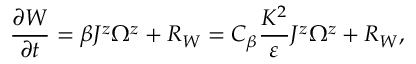Convert formula to latex. <formula><loc_0><loc_0><loc_500><loc_500>\frac { \partial W } { \partial t } = \beta J ^ { z } \Omega ^ { z } + R _ { W } = C _ { \beta } \frac { K ^ { 2 } } { \varepsilon } J ^ { z } \Omega ^ { z } + R _ { W } ,</formula> 